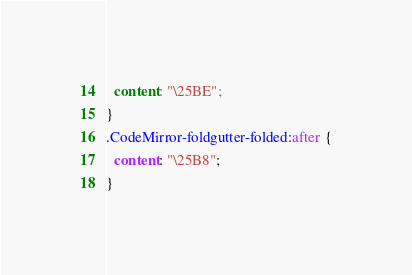<code> <loc_0><loc_0><loc_500><loc_500><_CSS_>  content: "\25BE";
}
.CodeMirror-foldgutter-folded:after {
  content: "\25B8";
}
</code> 